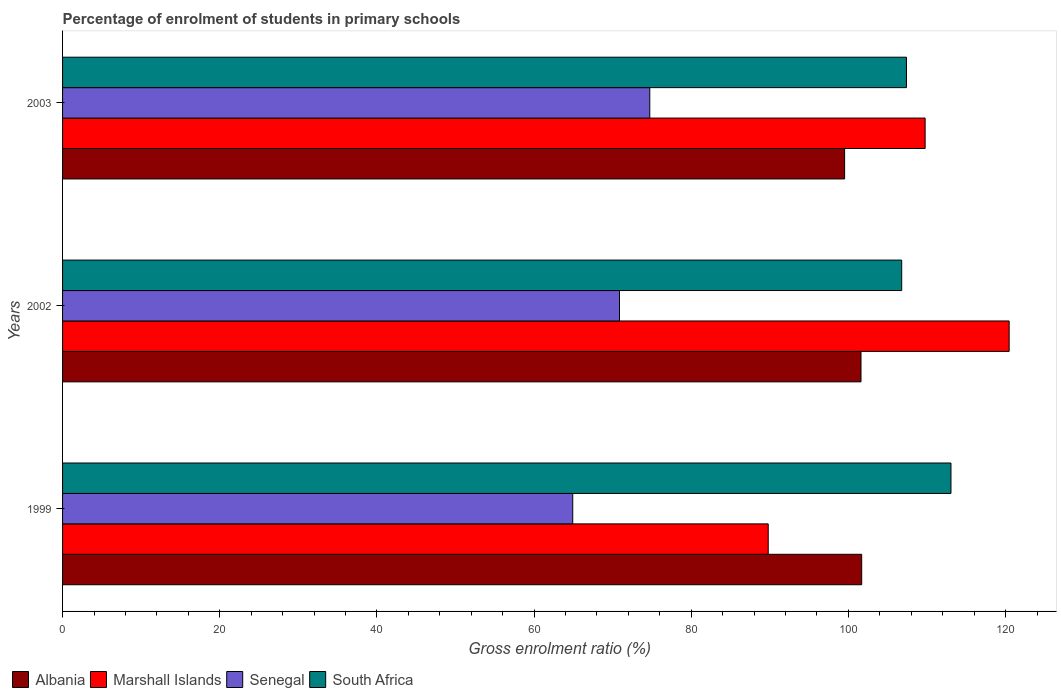How many different coloured bars are there?
Ensure brevity in your answer.  4. How many bars are there on the 1st tick from the top?
Your answer should be compact. 4. In how many cases, is the number of bars for a given year not equal to the number of legend labels?
Your answer should be compact. 0. What is the percentage of students enrolled in primary schools in South Africa in 1999?
Your answer should be compact. 113.05. Across all years, what is the maximum percentage of students enrolled in primary schools in Marshall Islands?
Make the answer very short. 120.45. Across all years, what is the minimum percentage of students enrolled in primary schools in South Africa?
Your response must be concise. 106.78. In which year was the percentage of students enrolled in primary schools in South Africa maximum?
Offer a terse response. 1999. What is the total percentage of students enrolled in primary schools in Senegal in the graph?
Give a very brief answer. 210.51. What is the difference between the percentage of students enrolled in primary schools in Albania in 2002 and that in 2003?
Your answer should be very brief. 2.09. What is the difference between the percentage of students enrolled in primary schools in Senegal in 1999 and the percentage of students enrolled in primary schools in South Africa in 2003?
Provide a succinct answer. -42.47. What is the average percentage of students enrolled in primary schools in Albania per year?
Make the answer very short. 100.93. In the year 1999, what is the difference between the percentage of students enrolled in primary schools in South Africa and percentage of students enrolled in primary schools in Marshall Islands?
Make the answer very short. 23.25. In how many years, is the percentage of students enrolled in primary schools in Albania greater than 104 %?
Your answer should be compact. 0. What is the ratio of the percentage of students enrolled in primary schools in Senegal in 2002 to that in 2003?
Offer a very short reply. 0.95. Is the percentage of students enrolled in primary schools in Marshall Islands in 1999 less than that in 2003?
Your response must be concise. Yes. What is the difference between the highest and the second highest percentage of students enrolled in primary schools in Senegal?
Make the answer very short. 3.86. What is the difference between the highest and the lowest percentage of students enrolled in primary schools in Albania?
Provide a succinct answer. 2.17. In how many years, is the percentage of students enrolled in primary schools in Marshall Islands greater than the average percentage of students enrolled in primary schools in Marshall Islands taken over all years?
Give a very brief answer. 2. What does the 3rd bar from the top in 2002 represents?
Make the answer very short. Marshall Islands. What does the 1st bar from the bottom in 2003 represents?
Offer a terse response. Albania. Are all the bars in the graph horizontal?
Ensure brevity in your answer.  Yes. How many years are there in the graph?
Your answer should be compact. 3. What is the difference between two consecutive major ticks on the X-axis?
Ensure brevity in your answer.  20. Does the graph contain any zero values?
Your answer should be compact. No. Does the graph contain grids?
Provide a short and direct response. No. Where does the legend appear in the graph?
Give a very brief answer. Bottom left. How many legend labels are there?
Provide a short and direct response. 4. How are the legend labels stacked?
Provide a short and direct response. Horizontal. What is the title of the graph?
Your response must be concise. Percentage of enrolment of students in primary schools. Does "Tuvalu" appear as one of the legend labels in the graph?
Provide a succinct answer. No. What is the label or title of the X-axis?
Give a very brief answer. Gross enrolment ratio (%). What is the label or title of the Y-axis?
Keep it short and to the point. Years. What is the Gross enrolment ratio (%) in Albania in 1999?
Offer a terse response. 101.69. What is the Gross enrolment ratio (%) of Marshall Islands in 1999?
Your answer should be compact. 89.79. What is the Gross enrolment ratio (%) in Senegal in 1999?
Offer a very short reply. 64.92. What is the Gross enrolment ratio (%) of South Africa in 1999?
Make the answer very short. 113.05. What is the Gross enrolment ratio (%) in Albania in 2002?
Offer a very short reply. 101.6. What is the Gross enrolment ratio (%) in Marshall Islands in 2002?
Offer a very short reply. 120.45. What is the Gross enrolment ratio (%) of Senegal in 2002?
Your answer should be compact. 70.87. What is the Gross enrolment ratio (%) in South Africa in 2002?
Offer a very short reply. 106.78. What is the Gross enrolment ratio (%) of Albania in 2003?
Provide a succinct answer. 99.52. What is the Gross enrolment ratio (%) of Marshall Islands in 2003?
Your response must be concise. 109.76. What is the Gross enrolment ratio (%) in Senegal in 2003?
Your response must be concise. 74.72. What is the Gross enrolment ratio (%) of South Africa in 2003?
Provide a short and direct response. 107.39. Across all years, what is the maximum Gross enrolment ratio (%) in Albania?
Offer a very short reply. 101.69. Across all years, what is the maximum Gross enrolment ratio (%) of Marshall Islands?
Provide a succinct answer. 120.45. Across all years, what is the maximum Gross enrolment ratio (%) of Senegal?
Offer a terse response. 74.72. Across all years, what is the maximum Gross enrolment ratio (%) in South Africa?
Provide a succinct answer. 113.05. Across all years, what is the minimum Gross enrolment ratio (%) of Albania?
Your answer should be compact. 99.52. Across all years, what is the minimum Gross enrolment ratio (%) of Marshall Islands?
Offer a terse response. 89.79. Across all years, what is the minimum Gross enrolment ratio (%) of Senegal?
Provide a succinct answer. 64.92. Across all years, what is the minimum Gross enrolment ratio (%) in South Africa?
Provide a succinct answer. 106.78. What is the total Gross enrolment ratio (%) of Albania in the graph?
Provide a succinct answer. 302.8. What is the total Gross enrolment ratio (%) of Marshall Islands in the graph?
Your answer should be very brief. 320.01. What is the total Gross enrolment ratio (%) of Senegal in the graph?
Offer a terse response. 210.51. What is the total Gross enrolment ratio (%) of South Africa in the graph?
Keep it short and to the point. 327.21. What is the difference between the Gross enrolment ratio (%) of Albania in 1999 and that in 2002?
Your answer should be compact. 0.09. What is the difference between the Gross enrolment ratio (%) of Marshall Islands in 1999 and that in 2002?
Offer a terse response. -30.66. What is the difference between the Gross enrolment ratio (%) of Senegal in 1999 and that in 2002?
Your response must be concise. -5.95. What is the difference between the Gross enrolment ratio (%) in South Africa in 1999 and that in 2002?
Offer a very short reply. 6.27. What is the difference between the Gross enrolment ratio (%) of Albania in 1999 and that in 2003?
Offer a terse response. 2.17. What is the difference between the Gross enrolment ratio (%) in Marshall Islands in 1999 and that in 2003?
Keep it short and to the point. -19.97. What is the difference between the Gross enrolment ratio (%) of Senegal in 1999 and that in 2003?
Give a very brief answer. -9.8. What is the difference between the Gross enrolment ratio (%) of South Africa in 1999 and that in 2003?
Your response must be concise. 5.66. What is the difference between the Gross enrolment ratio (%) in Albania in 2002 and that in 2003?
Provide a short and direct response. 2.09. What is the difference between the Gross enrolment ratio (%) of Marshall Islands in 2002 and that in 2003?
Provide a short and direct response. 10.69. What is the difference between the Gross enrolment ratio (%) in Senegal in 2002 and that in 2003?
Your answer should be very brief. -3.86. What is the difference between the Gross enrolment ratio (%) in South Africa in 2002 and that in 2003?
Give a very brief answer. -0.6. What is the difference between the Gross enrolment ratio (%) of Albania in 1999 and the Gross enrolment ratio (%) of Marshall Islands in 2002?
Provide a short and direct response. -18.77. What is the difference between the Gross enrolment ratio (%) of Albania in 1999 and the Gross enrolment ratio (%) of Senegal in 2002?
Provide a succinct answer. 30.82. What is the difference between the Gross enrolment ratio (%) in Albania in 1999 and the Gross enrolment ratio (%) in South Africa in 2002?
Provide a short and direct response. -5.09. What is the difference between the Gross enrolment ratio (%) of Marshall Islands in 1999 and the Gross enrolment ratio (%) of Senegal in 2002?
Provide a succinct answer. 18.93. What is the difference between the Gross enrolment ratio (%) of Marshall Islands in 1999 and the Gross enrolment ratio (%) of South Africa in 2002?
Provide a succinct answer. -16.99. What is the difference between the Gross enrolment ratio (%) in Senegal in 1999 and the Gross enrolment ratio (%) in South Africa in 2002?
Your response must be concise. -41.86. What is the difference between the Gross enrolment ratio (%) of Albania in 1999 and the Gross enrolment ratio (%) of Marshall Islands in 2003?
Offer a very short reply. -8.07. What is the difference between the Gross enrolment ratio (%) in Albania in 1999 and the Gross enrolment ratio (%) in Senegal in 2003?
Give a very brief answer. 26.96. What is the difference between the Gross enrolment ratio (%) of Albania in 1999 and the Gross enrolment ratio (%) of South Africa in 2003?
Offer a very short reply. -5.7. What is the difference between the Gross enrolment ratio (%) in Marshall Islands in 1999 and the Gross enrolment ratio (%) in Senegal in 2003?
Your answer should be compact. 15.07. What is the difference between the Gross enrolment ratio (%) of Marshall Islands in 1999 and the Gross enrolment ratio (%) of South Africa in 2003?
Your answer should be very brief. -17.59. What is the difference between the Gross enrolment ratio (%) of Senegal in 1999 and the Gross enrolment ratio (%) of South Africa in 2003?
Give a very brief answer. -42.47. What is the difference between the Gross enrolment ratio (%) in Albania in 2002 and the Gross enrolment ratio (%) in Marshall Islands in 2003?
Keep it short and to the point. -8.16. What is the difference between the Gross enrolment ratio (%) in Albania in 2002 and the Gross enrolment ratio (%) in Senegal in 2003?
Your answer should be very brief. 26.88. What is the difference between the Gross enrolment ratio (%) in Albania in 2002 and the Gross enrolment ratio (%) in South Africa in 2003?
Make the answer very short. -5.78. What is the difference between the Gross enrolment ratio (%) in Marshall Islands in 2002 and the Gross enrolment ratio (%) in Senegal in 2003?
Your answer should be very brief. 45.73. What is the difference between the Gross enrolment ratio (%) of Marshall Islands in 2002 and the Gross enrolment ratio (%) of South Africa in 2003?
Ensure brevity in your answer.  13.07. What is the difference between the Gross enrolment ratio (%) in Senegal in 2002 and the Gross enrolment ratio (%) in South Africa in 2003?
Make the answer very short. -36.52. What is the average Gross enrolment ratio (%) of Albania per year?
Your response must be concise. 100.93. What is the average Gross enrolment ratio (%) in Marshall Islands per year?
Make the answer very short. 106.67. What is the average Gross enrolment ratio (%) in Senegal per year?
Offer a very short reply. 70.17. What is the average Gross enrolment ratio (%) of South Africa per year?
Make the answer very short. 109.07. In the year 1999, what is the difference between the Gross enrolment ratio (%) of Albania and Gross enrolment ratio (%) of Marshall Islands?
Keep it short and to the point. 11.89. In the year 1999, what is the difference between the Gross enrolment ratio (%) in Albania and Gross enrolment ratio (%) in Senegal?
Make the answer very short. 36.77. In the year 1999, what is the difference between the Gross enrolment ratio (%) of Albania and Gross enrolment ratio (%) of South Africa?
Offer a very short reply. -11.36. In the year 1999, what is the difference between the Gross enrolment ratio (%) in Marshall Islands and Gross enrolment ratio (%) in Senegal?
Your answer should be compact. 24.88. In the year 1999, what is the difference between the Gross enrolment ratio (%) of Marshall Islands and Gross enrolment ratio (%) of South Africa?
Offer a very short reply. -23.25. In the year 1999, what is the difference between the Gross enrolment ratio (%) in Senegal and Gross enrolment ratio (%) in South Africa?
Offer a very short reply. -48.13. In the year 2002, what is the difference between the Gross enrolment ratio (%) in Albania and Gross enrolment ratio (%) in Marshall Islands?
Provide a short and direct response. -18.85. In the year 2002, what is the difference between the Gross enrolment ratio (%) in Albania and Gross enrolment ratio (%) in Senegal?
Offer a terse response. 30.73. In the year 2002, what is the difference between the Gross enrolment ratio (%) of Albania and Gross enrolment ratio (%) of South Africa?
Offer a terse response. -5.18. In the year 2002, what is the difference between the Gross enrolment ratio (%) in Marshall Islands and Gross enrolment ratio (%) in Senegal?
Offer a very short reply. 49.59. In the year 2002, what is the difference between the Gross enrolment ratio (%) of Marshall Islands and Gross enrolment ratio (%) of South Africa?
Provide a succinct answer. 13.67. In the year 2002, what is the difference between the Gross enrolment ratio (%) in Senegal and Gross enrolment ratio (%) in South Africa?
Your answer should be very brief. -35.91. In the year 2003, what is the difference between the Gross enrolment ratio (%) of Albania and Gross enrolment ratio (%) of Marshall Islands?
Your answer should be compact. -10.25. In the year 2003, what is the difference between the Gross enrolment ratio (%) of Albania and Gross enrolment ratio (%) of Senegal?
Provide a short and direct response. 24.79. In the year 2003, what is the difference between the Gross enrolment ratio (%) of Albania and Gross enrolment ratio (%) of South Africa?
Offer a very short reply. -7.87. In the year 2003, what is the difference between the Gross enrolment ratio (%) in Marshall Islands and Gross enrolment ratio (%) in Senegal?
Offer a very short reply. 35.04. In the year 2003, what is the difference between the Gross enrolment ratio (%) of Marshall Islands and Gross enrolment ratio (%) of South Africa?
Offer a very short reply. 2.38. In the year 2003, what is the difference between the Gross enrolment ratio (%) in Senegal and Gross enrolment ratio (%) in South Africa?
Your answer should be very brief. -32.66. What is the ratio of the Gross enrolment ratio (%) of Albania in 1999 to that in 2002?
Offer a very short reply. 1. What is the ratio of the Gross enrolment ratio (%) in Marshall Islands in 1999 to that in 2002?
Make the answer very short. 0.75. What is the ratio of the Gross enrolment ratio (%) in Senegal in 1999 to that in 2002?
Give a very brief answer. 0.92. What is the ratio of the Gross enrolment ratio (%) in South Africa in 1999 to that in 2002?
Make the answer very short. 1.06. What is the ratio of the Gross enrolment ratio (%) in Albania in 1999 to that in 2003?
Provide a short and direct response. 1.02. What is the ratio of the Gross enrolment ratio (%) of Marshall Islands in 1999 to that in 2003?
Your answer should be very brief. 0.82. What is the ratio of the Gross enrolment ratio (%) in Senegal in 1999 to that in 2003?
Keep it short and to the point. 0.87. What is the ratio of the Gross enrolment ratio (%) of South Africa in 1999 to that in 2003?
Your answer should be very brief. 1.05. What is the ratio of the Gross enrolment ratio (%) in Marshall Islands in 2002 to that in 2003?
Offer a very short reply. 1.1. What is the ratio of the Gross enrolment ratio (%) of Senegal in 2002 to that in 2003?
Your answer should be compact. 0.95. What is the ratio of the Gross enrolment ratio (%) of South Africa in 2002 to that in 2003?
Ensure brevity in your answer.  0.99. What is the difference between the highest and the second highest Gross enrolment ratio (%) of Albania?
Make the answer very short. 0.09. What is the difference between the highest and the second highest Gross enrolment ratio (%) of Marshall Islands?
Offer a terse response. 10.69. What is the difference between the highest and the second highest Gross enrolment ratio (%) of Senegal?
Ensure brevity in your answer.  3.86. What is the difference between the highest and the second highest Gross enrolment ratio (%) of South Africa?
Your answer should be very brief. 5.66. What is the difference between the highest and the lowest Gross enrolment ratio (%) in Albania?
Your response must be concise. 2.17. What is the difference between the highest and the lowest Gross enrolment ratio (%) in Marshall Islands?
Make the answer very short. 30.66. What is the difference between the highest and the lowest Gross enrolment ratio (%) in Senegal?
Keep it short and to the point. 9.8. What is the difference between the highest and the lowest Gross enrolment ratio (%) of South Africa?
Offer a very short reply. 6.27. 